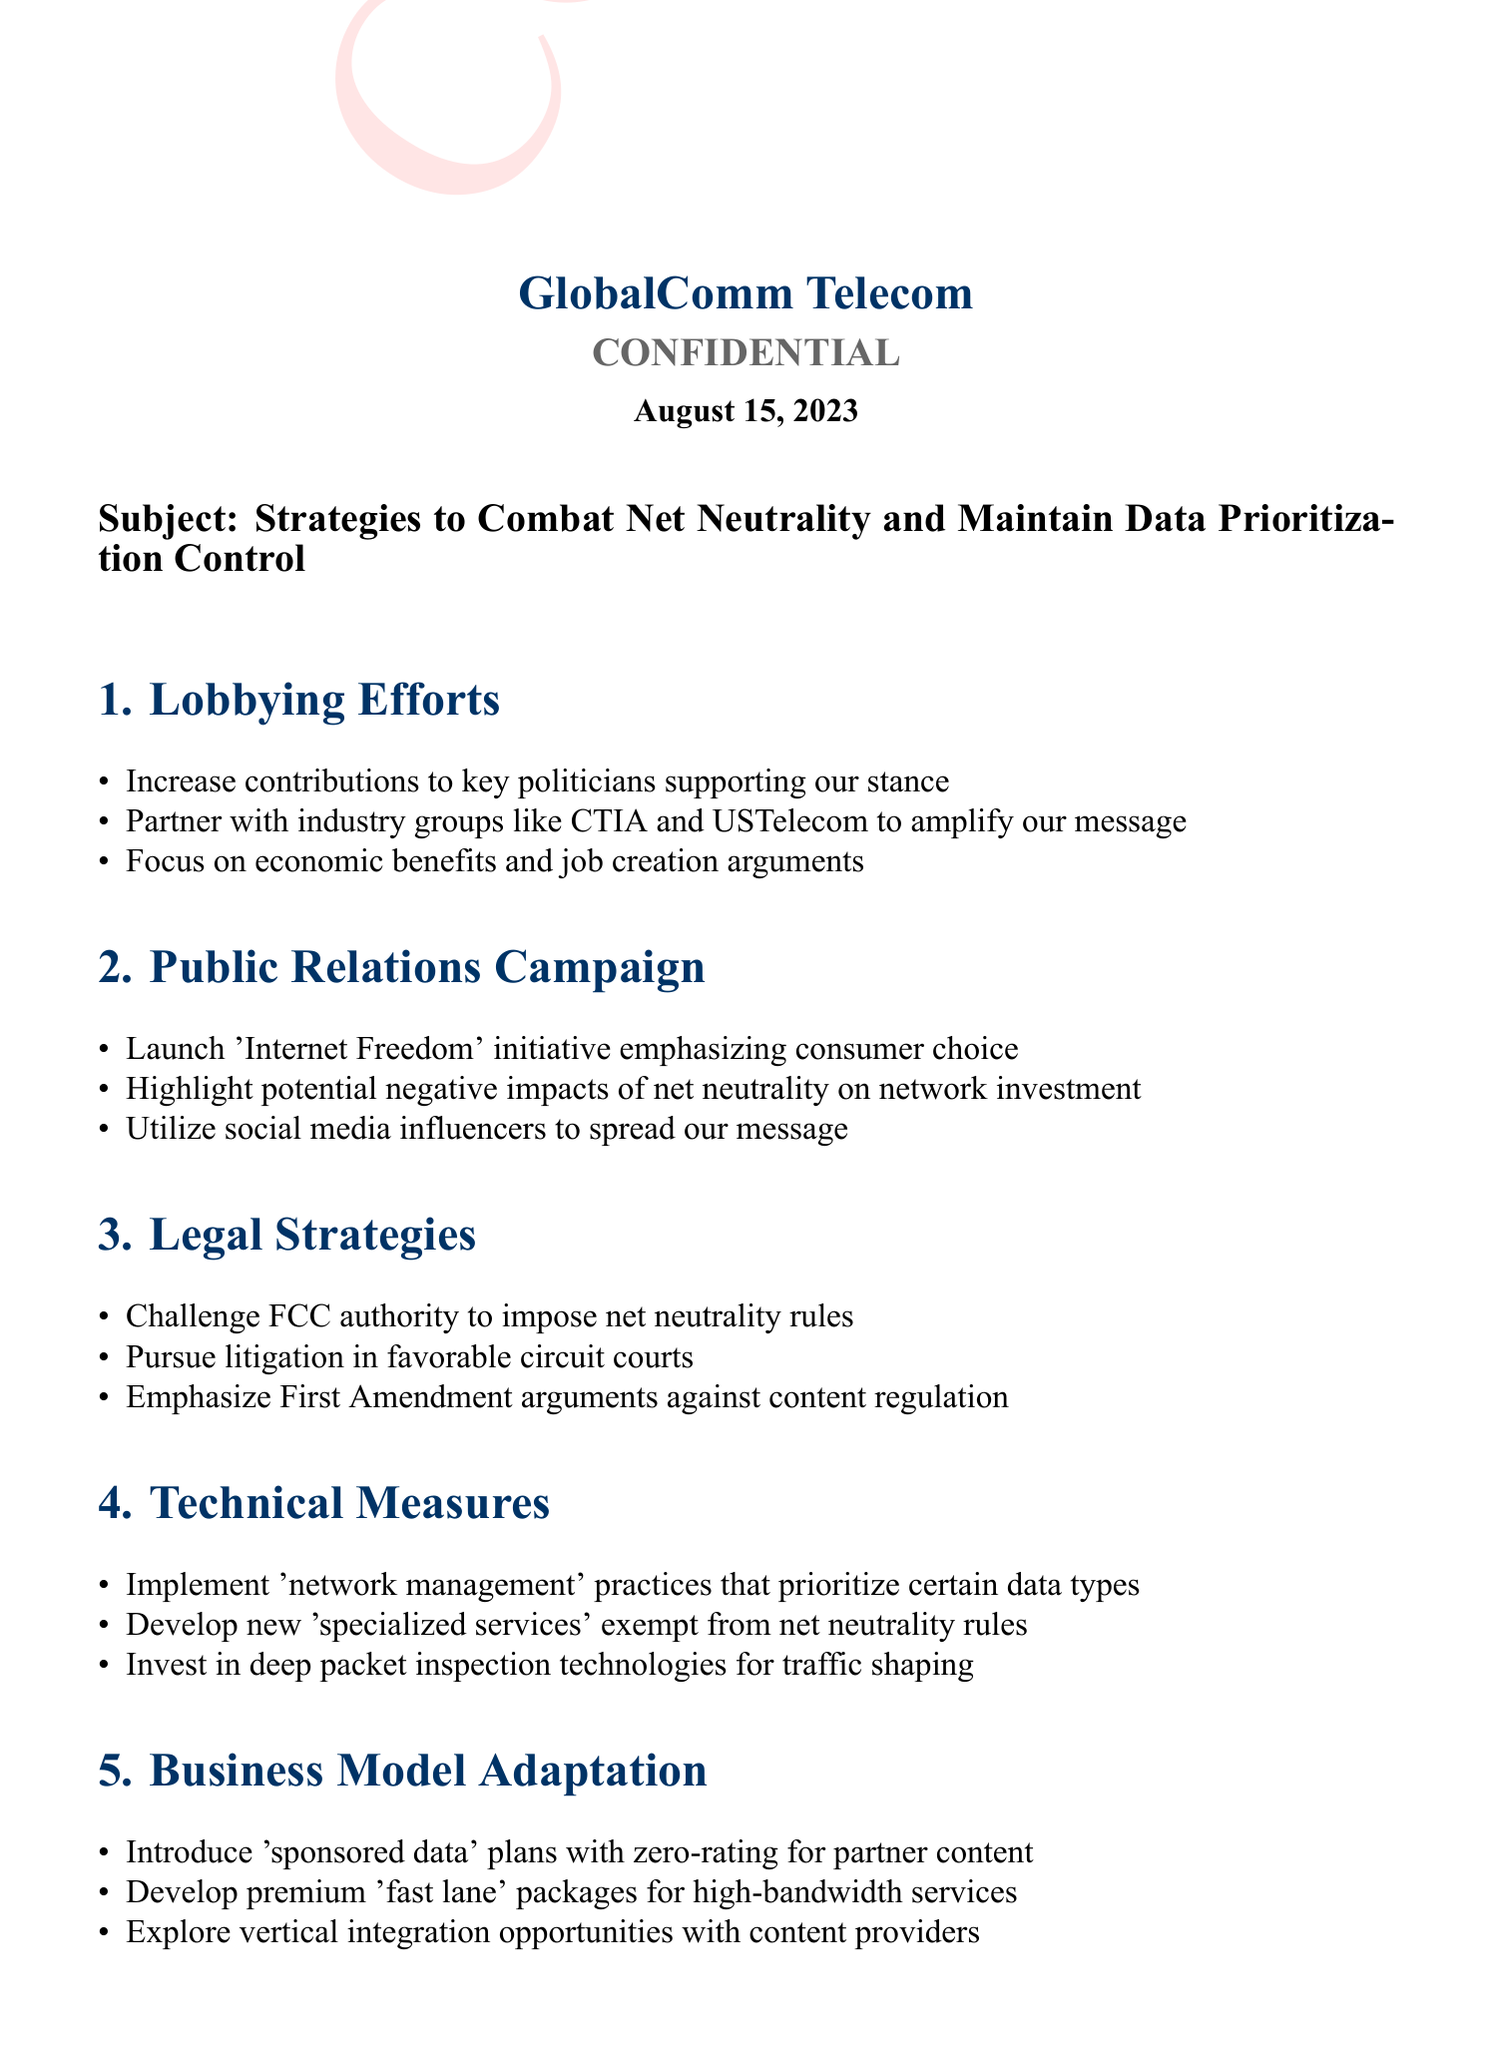What is the document's date? The date is mentioned prominently in the heading of the document.
Answer: August 15, 2023 Who authored the document? The author's name is provided at the end, indicating the official behind the memo.
Answer: James R. Thompson What is the primary subject of the memo? The subject line states the focus of the memo explicitly.
Answer: Strategies to Combat Net Neutrality and Maintain Data Prioritization Control Which segment discusses lobbying efforts? The section titled "Lobbying Efforts" outlines specific strategies in that area.
Answer: 1 What are the listed legal strategies? The section titled "Legal Strategies" points out the approaches being considered.
Answer: Challenge FCC authority to impose net neutrality rules What public relations initiative is mentioned? The PR initiative is clearly labeled in the corresponding section.
Answer: 'Internet Freedom' initiative What technical measure involves prioritizing data types? The technical strategy directly refers to practices to manage data traffic.
Answer: 'Network management' practices What business model adaptation involves zero-rating? The adaptation that discusses zero-rating is explicitly named in that section.
Answer: 'Sponsored data' plans 